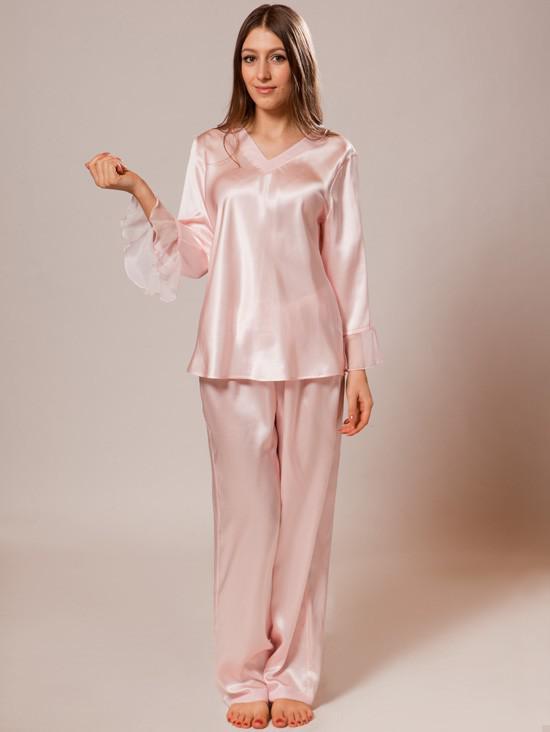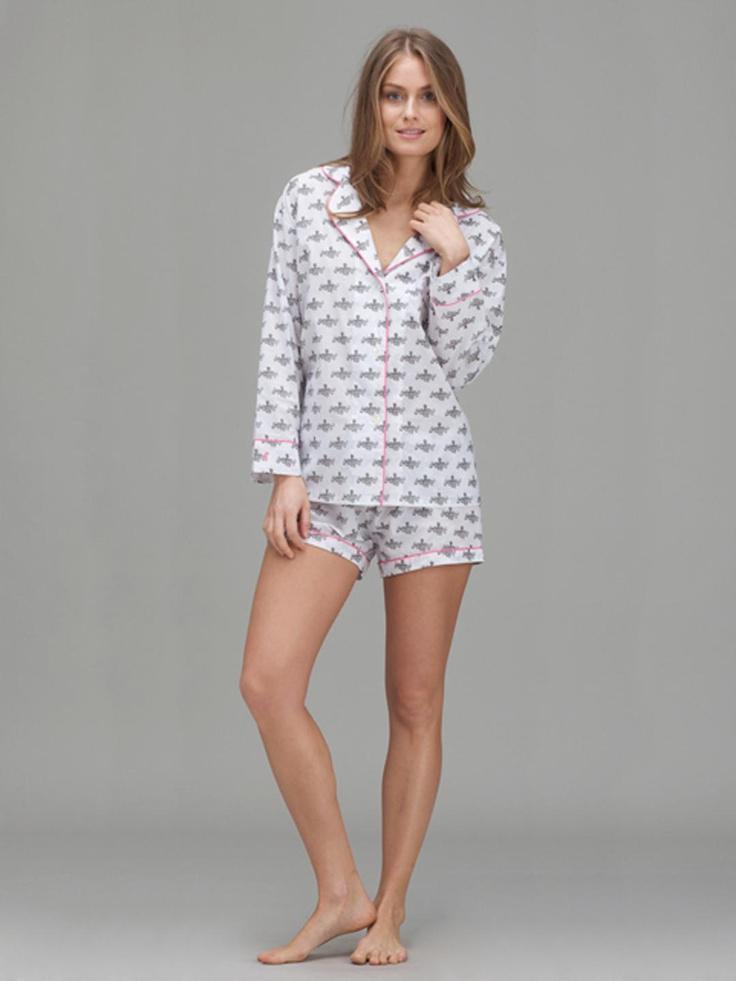The first image is the image on the left, the second image is the image on the right. Considering the images on both sides, is "Of two pajama sets, one is pink with long sleeves and pants, while the other is a matching set of top with short pants." valid? Answer yes or no. Yes. The first image is the image on the left, the second image is the image on the right. Examine the images to the left and right. Is the description "One woman wears shorts while the other wears pants." accurate? Answer yes or no. Yes. 